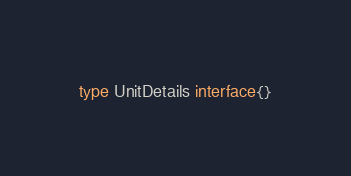Convert code to text. <code><loc_0><loc_0><loc_500><loc_500><_Go_>type UnitDetails interface{}
</code> 